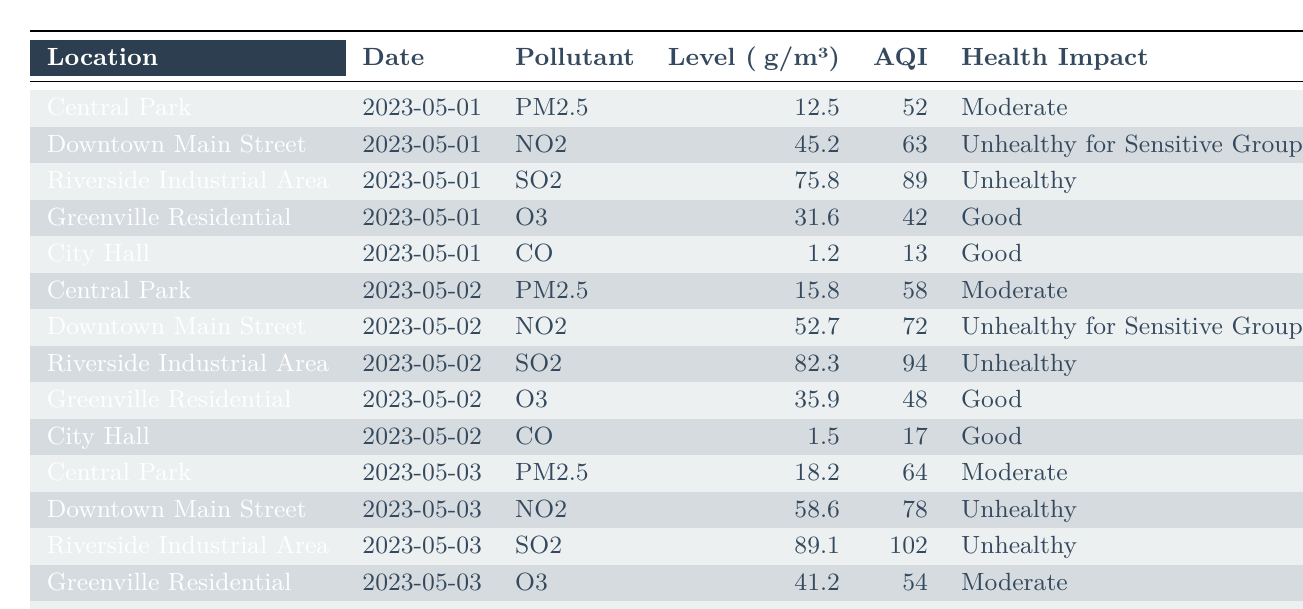What pollutant had the highest level recorded on May 2, 2023? On May 2, 2023, the pollutants measured were PM2.5 at Central Park (15.8 μg/m³), NO2 at Downtown Main Street (52.7 μg/m³), SO2 at Riverside Industrial Area (82.3 μg/m³), O3 at Greenville Residential (35.9 μg/m³), and CO at City Hall (1.5 μg/m³). The highest level is 82.3 μg/m³ for SO2 at Riverside Industrial Area.
Answer: SO2 What was the AQI for the Downtown Main Street on May 3, 2023? The AQI recorded for Downtown Main Street on May 3, 2023, is noted in the table, which shows it as 78 for the NO2 level.
Answer: 78 What is the average level of PM2.5 over the three days recorded? The levels of PM2.5 recorded over the three days are 12.5, 15.8, and 18.2 μg/m³. To find the average, add these values: 12.5 + 15.8 + 18.2 = 46.5. Then divide by 3, resulting in 46.5 / 3 = 15.5.
Answer: 15.5 Is the air quality at City Hall considered good on all recorded dates? Checking the health impact for City Hall over the three dates, it is noted as 'Good' on all dates (May 1, 2, and 3). Therefore, the air quality is consistently good.
Answer: Yes Which location experienced the most significant increase in SO2 levels from May 1 to May 3, 2023? The SO2 levels at Riverside Industrial Area on May 1, 2023, are 75.8 μg/m³, and on May 3, 2023, it increased to 89.1 μg/m³. The increase is calculated as 89.1 - 75.8 = 13.3 μg/m³. No other location recorded SO2, thus this is the only instance to analyze.
Answer: Riverside Industrial Area What was the health impact of pollutants at Greenville Residential on May 3, 2023? On this date, the pollutant at Greenville Residential was O3, and the table notes the health impact as 'Moderate.'
Answer: Moderate Which location had the highest AQI recorded during the observations? The highest AQI recorded is noted for Riverside Industrial Area on May 3, 2023, at 102 for SO2, which is the highest value when compared with other locations and days.
Answer: 102 How does the level of NO2 change from May 1 to May 2, 2023, in Downtown Main Street? The level of NO2 on May 1 was 45.2 μg/m³, and on May 2, it was 52.7 μg/m³. The change is calculated as 52.7 - 45.2 = 7.5 μg/m³, indicating an increase.
Answer: Increase of 7.5 μg/m³ On which day was the level of O3 in Greenville Residential the highest? The recorded O3 levels are 31.6 μg/m³ on May 1, 35.9 μg/m³ on May 2, and 41.2 μg/m³ on May 3. The highest value is 41.2 μg/m³ on May 3, thus that day had the maximum level.
Answer: May 3, 2023 